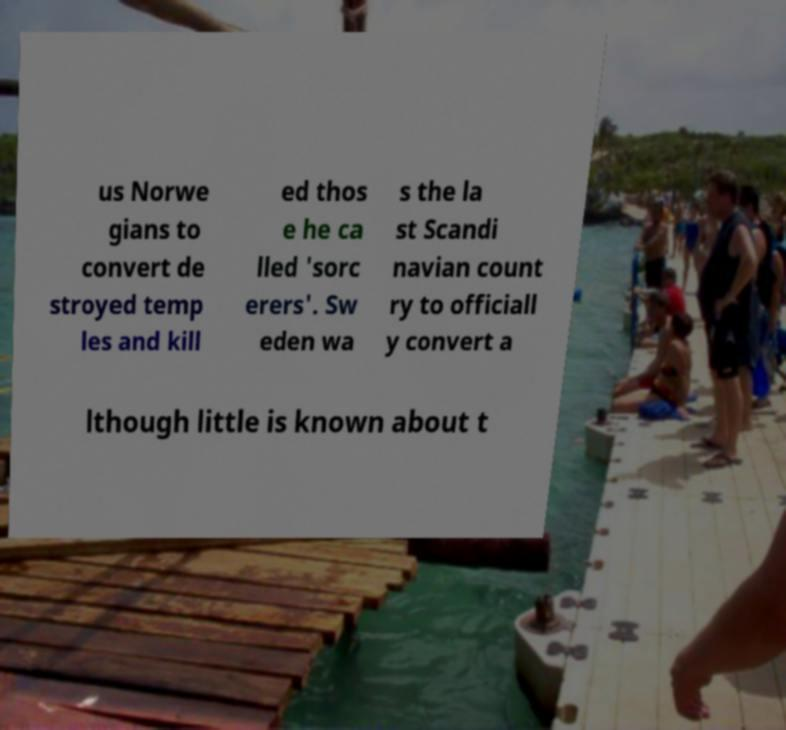Could you extract and type out the text from this image? us Norwe gians to convert de stroyed temp les and kill ed thos e he ca lled 'sorc erers'. Sw eden wa s the la st Scandi navian count ry to officiall y convert a lthough little is known about t 